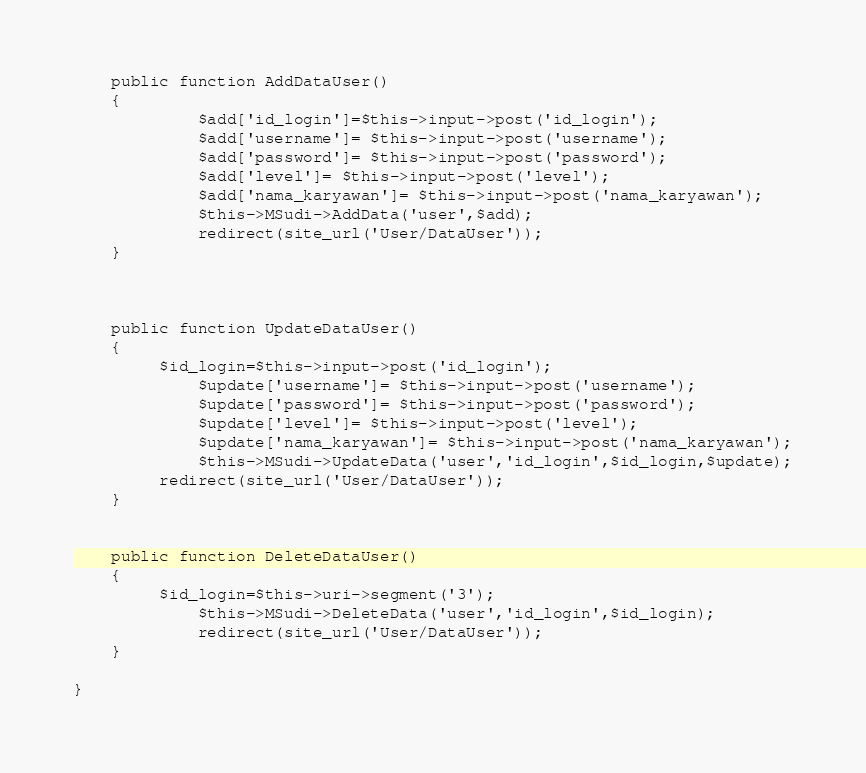Convert code to text. <code><loc_0><loc_0><loc_500><loc_500><_PHP_>	public function AddDataUser()
	{
		 	 $add['id_login']=$this->input->post('id_login');
         	 $add['username']= $this->input->post('username');
         	 $add['password']= $this->input->post('password');  
         	 $add['level']= $this->input->post('level');
         	 $add['nama_karyawan']= $this->input->post('nama_karyawan');
        	 $this->MSudi->AddData('user',$add);
        	 redirect(site_url('User/DataUser'));
	}



	public function UpdateDataUser()
	{
		 $id_login=$this->input->post('id_login');
		 	 $update['username']= $this->input->post('username');
         	 $update['password']= $this->input->post('password');
         	 $update['level']= $this->input->post('level');
         	 $update['nama_karyawan']= $this->input->post('nama_karyawan');
          	 $this->MSudi->UpdateData('user','id_login',$id_login,$update);
		 redirect(site_url('User/DataUser'));
	}


	public function DeleteDataUser()
	{
		 $id_login=$this->uri->segment('3');
        	 $this->MSudi->DeleteData('user','id_login',$id_login);
        	 redirect(site_url('User/DataUser'));
	}

}</code> 